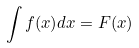<formula> <loc_0><loc_0><loc_500><loc_500>\int f ( x ) d x = F ( x )</formula> 